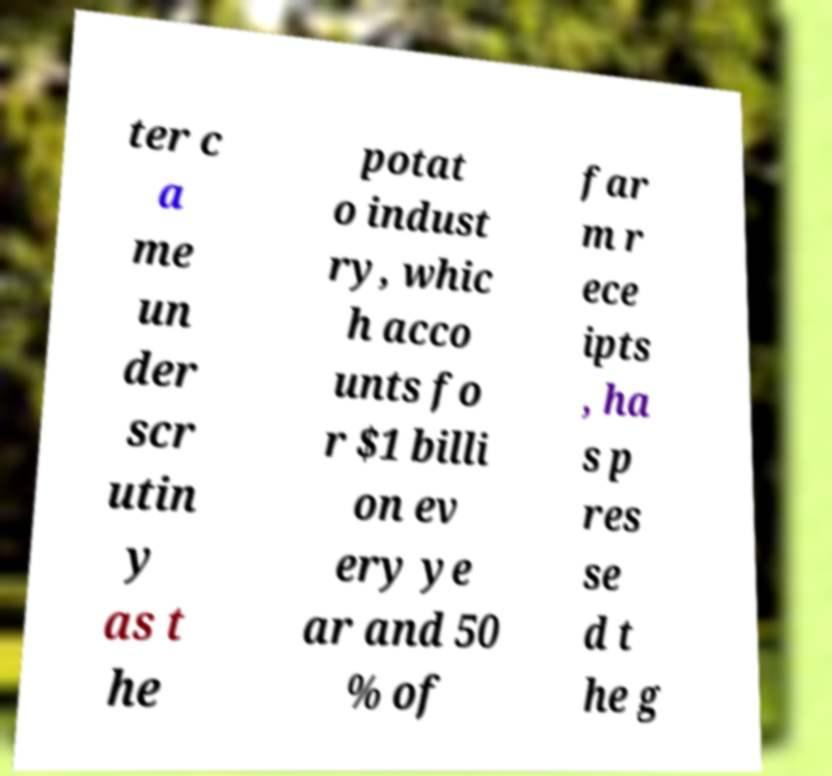Please read and relay the text visible in this image. What does it say? ter c a me un der scr utin y as t he potat o indust ry, whic h acco unts fo r $1 billi on ev ery ye ar and 50 % of far m r ece ipts , ha s p res se d t he g 